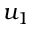<formula> <loc_0><loc_0><loc_500><loc_500>u _ { 1 }</formula> 